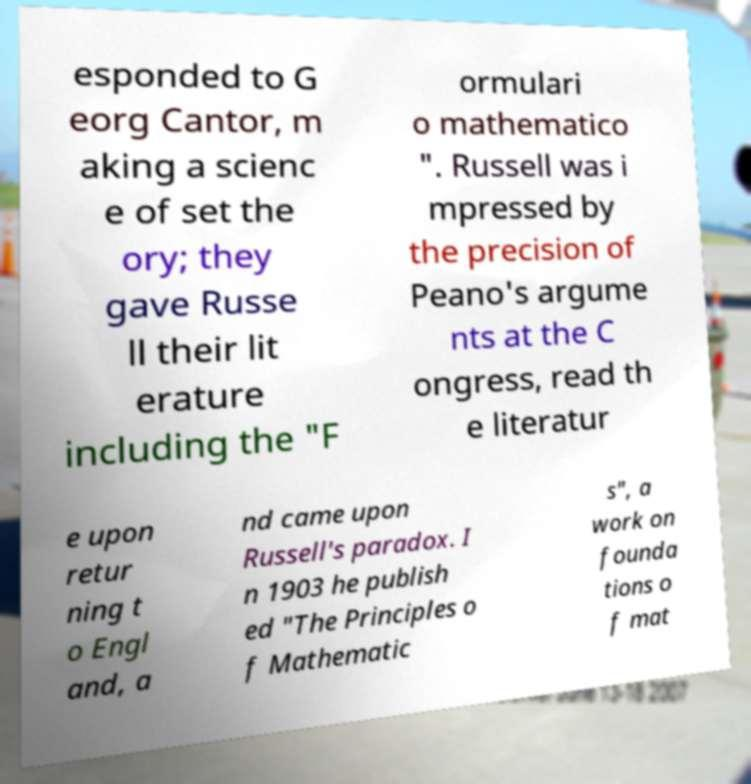What messages or text are displayed in this image? I need them in a readable, typed format. esponded to G eorg Cantor, m aking a scienc e of set the ory; they gave Russe ll their lit erature including the "F ormulari o mathematico ". Russell was i mpressed by the precision of Peano's argume nts at the C ongress, read th e literatur e upon retur ning t o Engl and, a nd came upon Russell's paradox. I n 1903 he publish ed "The Principles o f Mathematic s", a work on founda tions o f mat 